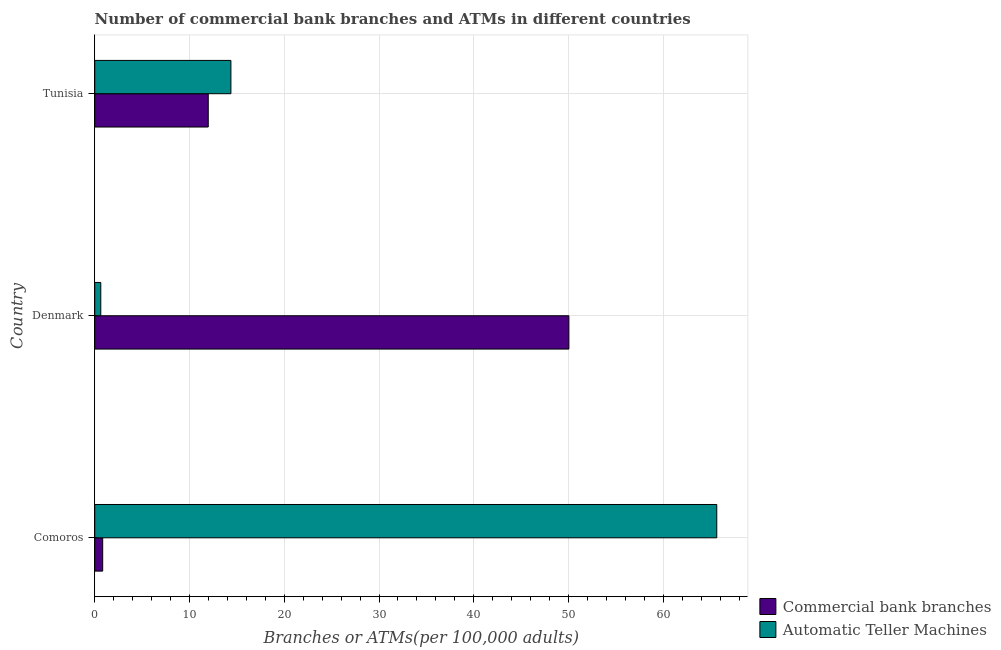How many different coloured bars are there?
Your answer should be compact. 2. How many groups of bars are there?
Give a very brief answer. 3. Are the number of bars per tick equal to the number of legend labels?
Your answer should be compact. Yes. Are the number of bars on each tick of the Y-axis equal?
Provide a succinct answer. Yes. What is the label of the 1st group of bars from the top?
Provide a succinct answer. Tunisia. In how many cases, is the number of bars for a given country not equal to the number of legend labels?
Give a very brief answer. 0. What is the number of atms in Comoros?
Give a very brief answer. 65.64. Across all countries, what is the maximum number of commercal bank branches?
Offer a terse response. 50.03. Across all countries, what is the minimum number of commercal bank branches?
Give a very brief answer. 0.84. In which country was the number of commercal bank branches maximum?
Ensure brevity in your answer.  Denmark. What is the total number of atms in the graph?
Provide a succinct answer. 80.65. What is the difference between the number of commercal bank branches in Comoros and the number of atms in Tunisia?
Provide a succinct answer. -13.53. What is the average number of atms per country?
Ensure brevity in your answer.  26.88. What is the difference between the number of atms and number of commercal bank branches in Comoros?
Provide a succinct answer. 64.8. What is the ratio of the number of commercal bank branches in Denmark to that in Tunisia?
Give a very brief answer. 4.18. What is the difference between the highest and the second highest number of atms?
Ensure brevity in your answer.  51.27. What is the difference between the highest and the lowest number of commercal bank branches?
Offer a terse response. 49.19. What does the 2nd bar from the top in Denmark represents?
Offer a terse response. Commercial bank branches. What does the 2nd bar from the bottom in Comoros represents?
Give a very brief answer. Automatic Teller Machines. How many bars are there?
Give a very brief answer. 6. Does the graph contain any zero values?
Keep it short and to the point. No. Does the graph contain grids?
Keep it short and to the point. Yes. How many legend labels are there?
Your response must be concise. 2. What is the title of the graph?
Give a very brief answer. Number of commercial bank branches and ATMs in different countries. What is the label or title of the X-axis?
Your answer should be very brief. Branches or ATMs(per 100,0 adults). What is the label or title of the Y-axis?
Give a very brief answer. Country. What is the Branches or ATMs(per 100,000 adults) in Commercial bank branches in Comoros?
Make the answer very short. 0.84. What is the Branches or ATMs(per 100,000 adults) of Automatic Teller Machines in Comoros?
Offer a very short reply. 65.64. What is the Branches or ATMs(per 100,000 adults) of Commercial bank branches in Denmark?
Ensure brevity in your answer.  50.03. What is the Branches or ATMs(per 100,000 adults) of Automatic Teller Machines in Denmark?
Offer a terse response. 0.64. What is the Branches or ATMs(per 100,000 adults) of Commercial bank branches in Tunisia?
Give a very brief answer. 11.98. What is the Branches or ATMs(per 100,000 adults) of Automatic Teller Machines in Tunisia?
Make the answer very short. 14.37. Across all countries, what is the maximum Branches or ATMs(per 100,000 adults) in Commercial bank branches?
Provide a short and direct response. 50.03. Across all countries, what is the maximum Branches or ATMs(per 100,000 adults) of Automatic Teller Machines?
Offer a terse response. 65.64. Across all countries, what is the minimum Branches or ATMs(per 100,000 adults) in Commercial bank branches?
Offer a terse response. 0.84. Across all countries, what is the minimum Branches or ATMs(per 100,000 adults) of Automatic Teller Machines?
Give a very brief answer. 0.64. What is the total Branches or ATMs(per 100,000 adults) in Commercial bank branches in the graph?
Keep it short and to the point. 62.85. What is the total Branches or ATMs(per 100,000 adults) in Automatic Teller Machines in the graph?
Your answer should be compact. 80.65. What is the difference between the Branches or ATMs(per 100,000 adults) in Commercial bank branches in Comoros and that in Denmark?
Your answer should be very brief. -49.19. What is the difference between the Branches or ATMs(per 100,000 adults) of Automatic Teller Machines in Comoros and that in Denmark?
Offer a terse response. 65. What is the difference between the Branches or ATMs(per 100,000 adults) of Commercial bank branches in Comoros and that in Tunisia?
Keep it short and to the point. -11.14. What is the difference between the Branches or ATMs(per 100,000 adults) in Automatic Teller Machines in Comoros and that in Tunisia?
Make the answer very short. 51.27. What is the difference between the Branches or ATMs(per 100,000 adults) of Commercial bank branches in Denmark and that in Tunisia?
Your answer should be very brief. 38.05. What is the difference between the Branches or ATMs(per 100,000 adults) of Automatic Teller Machines in Denmark and that in Tunisia?
Your response must be concise. -13.73. What is the difference between the Branches or ATMs(per 100,000 adults) in Commercial bank branches in Comoros and the Branches or ATMs(per 100,000 adults) in Automatic Teller Machines in Denmark?
Offer a terse response. 0.2. What is the difference between the Branches or ATMs(per 100,000 adults) of Commercial bank branches in Comoros and the Branches or ATMs(per 100,000 adults) of Automatic Teller Machines in Tunisia?
Your response must be concise. -13.53. What is the difference between the Branches or ATMs(per 100,000 adults) of Commercial bank branches in Denmark and the Branches or ATMs(per 100,000 adults) of Automatic Teller Machines in Tunisia?
Your response must be concise. 35.66. What is the average Branches or ATMs(per 100,000 adults) in Commercial bank branches per country?
Provide a short and direct response. 20.95. What is the average Branches or ATMs(per 100,000 adults) of Automatic Teller Machines per country?
Make the answer very short. 26.88. What is the difference between the Branches or ATMs(per 100,000 adults) in Commercial bank branches and Branches or ATMs(per 100,000 adults) in Automatic Teller Machines in Comoros?
Keep it short and to the point. -64.8. What is the difference between the Branches or ATMs(per 100,000 adults) of Commercial bank branches and Branches or ATMs(per 100,000 adults) of Automatic Teller Machines in Denmark?
Keep it short and to the point. 49.4. What is the difference between the Branches or ATMs(per 100,000 adults) in Commercial bank branches and Branches or ATMs(per 100,000 adults) in Automatic Teller Machines in Tunisia?
Offer a very short reply. -2.39. What is the ratio of the Branches or ATMs(per 100,000 adults) in Commercial bank branches in Comoros to that in Denmark?
Ensure brevity in your answer.  0.02. What is the ratio of the Branches or ATMs(per 100,000 adults) in Automatic Teller Machines in Comoros to that in Denmark?
Your response must be concise. 102.88. What is the ratio of the Branches or ATMs(per 100,000 adults) of Commercial bank branches in Comoros to that in Tunisia?
Offer a terse response. 0.07. What is the ratio of the Branches or ATMs(per 100,000 adults) of Automatic Teller Machines in Comoros to that in Tunisia?
Give a very brief answer. 4.57. What is the ratio of the Branches or ATMs(per 100,000 adults) in Commercial bank branches in Denmark to that in Tunisia?
Provide a succinct answer. 4.18. What is the ratio of the Branches or ATMs(per 100,000 adults) of Automatic Teller Machines in Denmark to that in Tunisia?
Provide a succinct answer. 0.04. What is the difference between the highest and the second highest Branches or ATMs(per 100,000 adults) in Commercial bank branches?
Your response must be concise. 38.05. What is the difference between the highest and the second highest Branches or ATMs(per 100,000 adults) in Automatic Teller Machines?
Your answer should be compact. 51.27. What is the difference between the highest and the lowest Branches or ATMs(per 100,000 adults) in Commercial bank branches?
Offer a terse response. 49.19. What is the difference between the highest and the lowest Branches or ATMs(per 100,000 adults) of Automatic Teller Machines?
Your answer should be very brief. 65. 